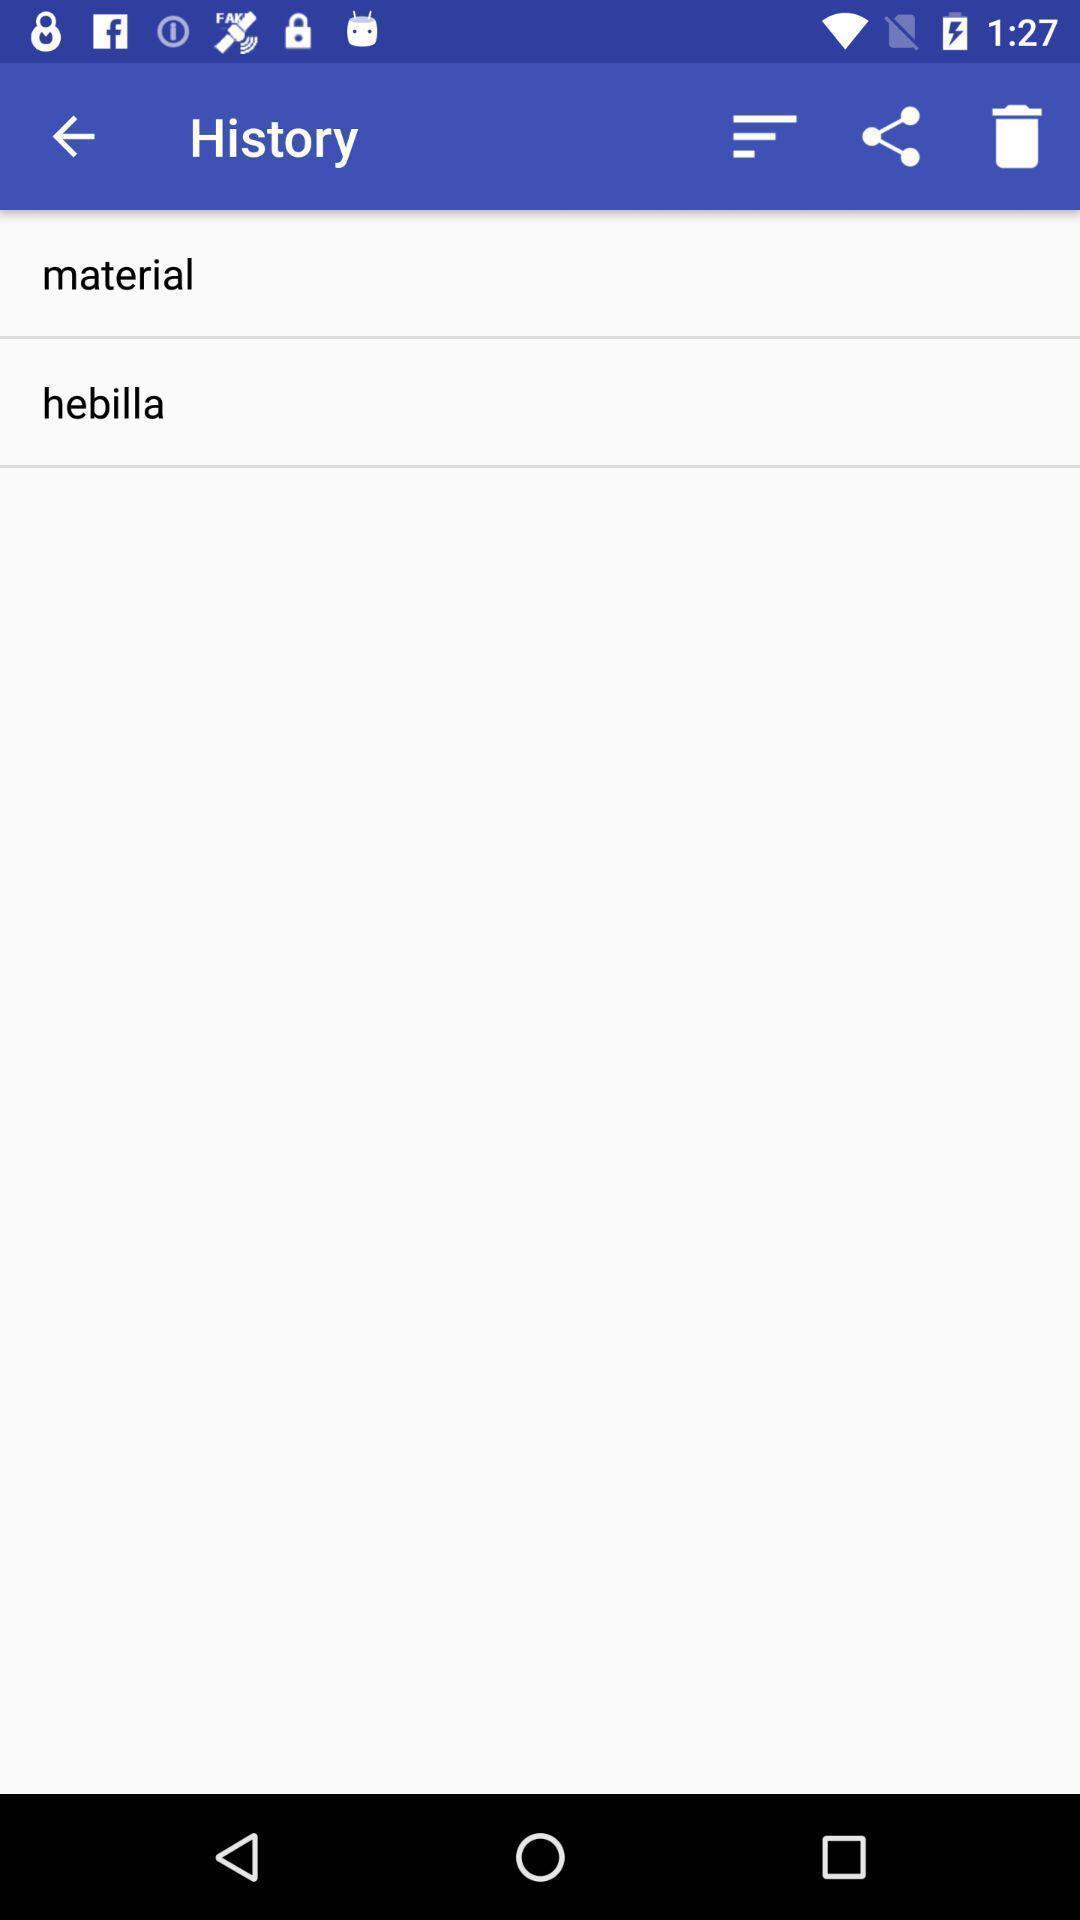Summarize the information in this screenshot. Window displaying the history page. 